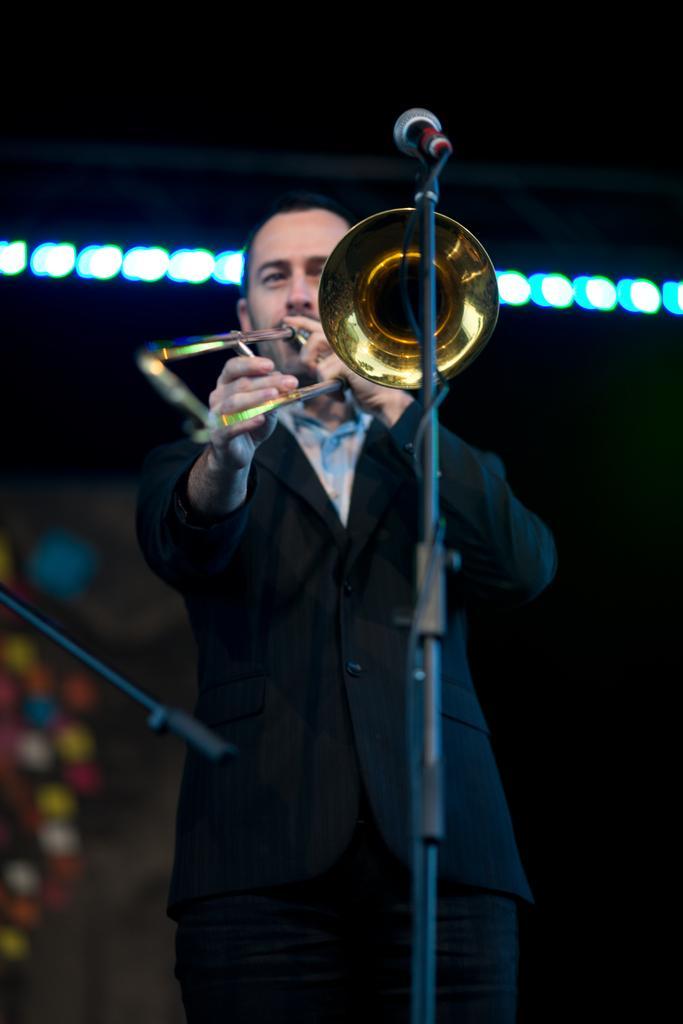How would you summarize this image in a sentence or two? In this image I can see a person standing and the person is wearing black and white color dress and the person is holding a musical instrument. In front I can see a microphone, background I can see few lights. 